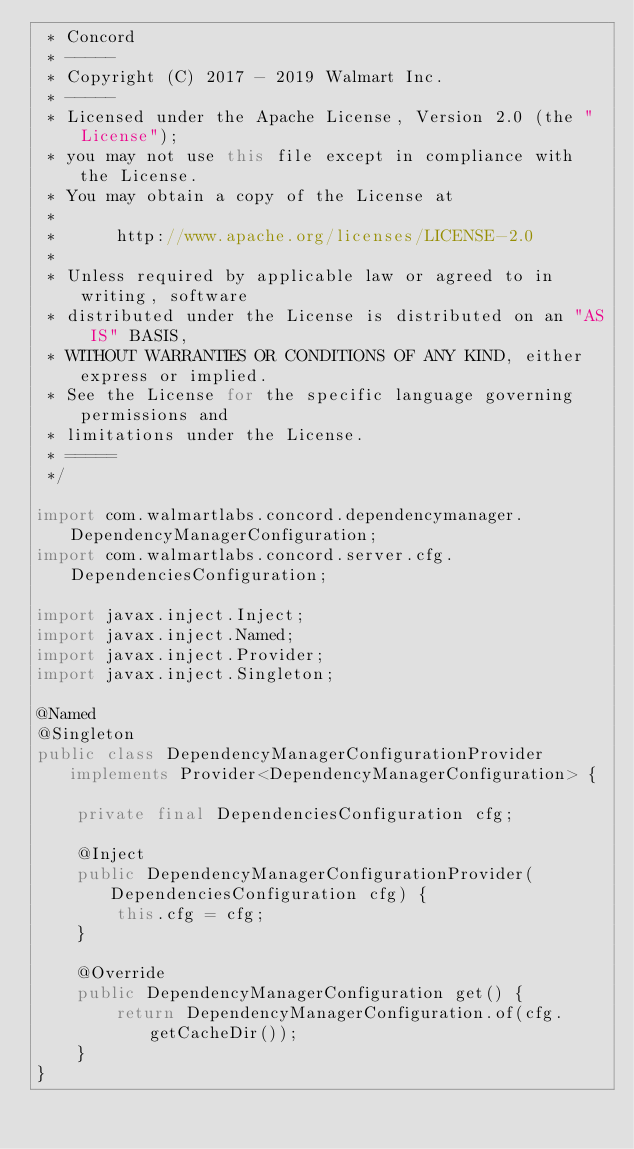Convert code to text. <code><loc_0><loc_0><loc_500><loc_500><_Java_> * Concord
 * -----
 * Copyright (C) 2017 - 2019 Walmart Inc.
 * -----
 * Licensed under the Apache License, Version 2.0 (the "License");
 * you may not use this file except in compliance with the License.
 * You may obtain a copy of the License at
 * 
 *      http://www.apache.org/licenses/LICENSE-2.0
 * 
 * Unless required by applicable law or agreed to in writing, software
 * distributed under the License is distributed on an "AS IS" BASIS,
 * WITHOUT WARRANTIES OR CONDITIONS OF ANY KIND, either express or implied.
 * See the License for the specific language governing permissions and
 * limitations under the License.
 * =====
 */

import com.walmartlabs.concord.dependencymanager.DependencyManagerConfiguration;
import com.walmartlabs.concord.server.cfg.DependenciesConfiguration;

import javax.inject.Inject;
import javax.inject.Named;
import javax.inject.Provider;
import javax.inject.Singleton;

@Named
@Singleton
public class DependencyManagerConfigurationProvider implements Provider<DependencyManagerConfiguration> {

    private final DependenciesConfiguration cfg;

    @Inject
    public DependencyManagerConfigurationProvider(DependenciesConfiguration cfg) {
        this.cfg = cfg;
    }

    @Override
    public DependencyManagerConfiguration get() {
        return DependencyManagerConfiguration.of(cfg.getCacheDir());
    }
}
</code> 